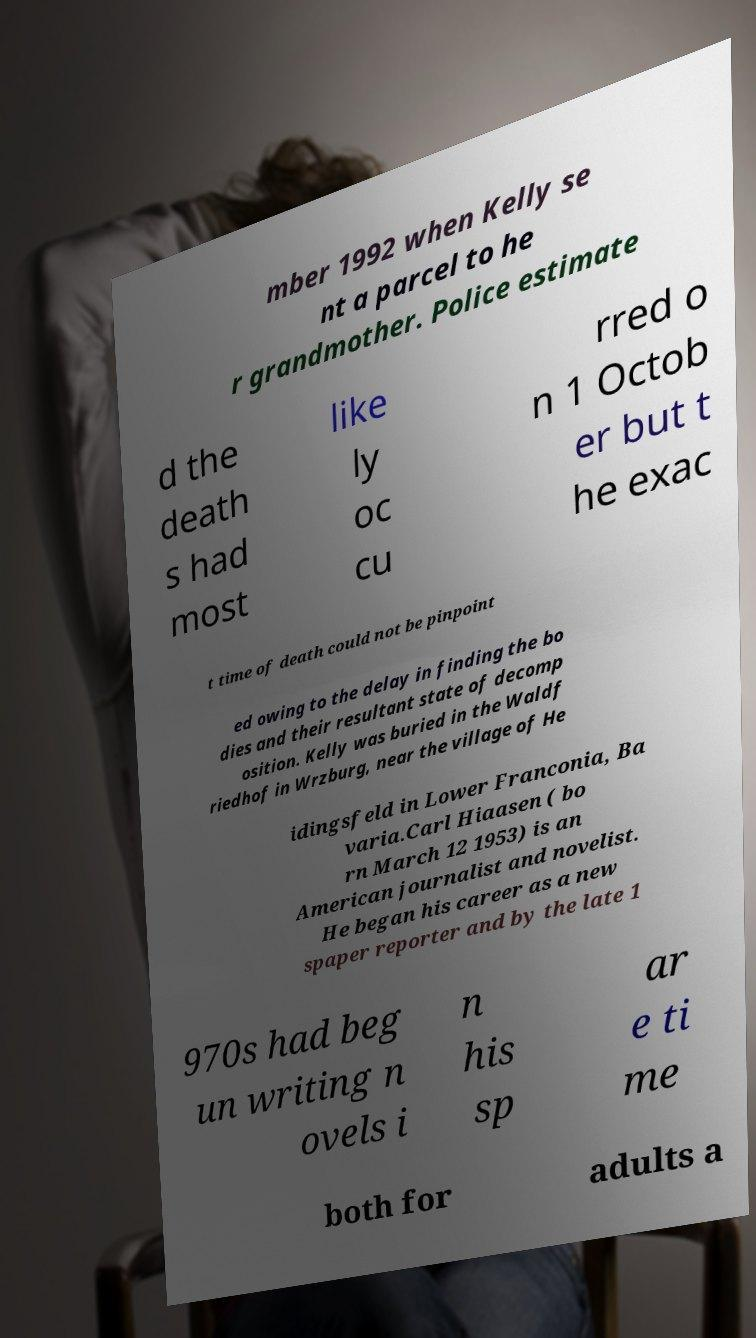Please read and relay the text visible in this image. What does it say? mber 1992 when Kelly se nt a parcel to he r grandmother. Police estimate d the death s had most like ly oc cu rred o n 1 Octob er but t he exac t time of death could not be pinpoint ed owing to the delay in finding the bo dies and their resultant state of decomp osition. Kelly was buried in the Waldf riedhof in Wrzburg, near the village of He idingsfeld in Lower Franconia, Ba varia.Carl Hiaasen ( bo rn March 12 1953) is an American journalist and novelist. He began his career as a new spaper reporter and by the late 1 970s had beg un writing n ovels i n his sp ar e ti me both for adults a 